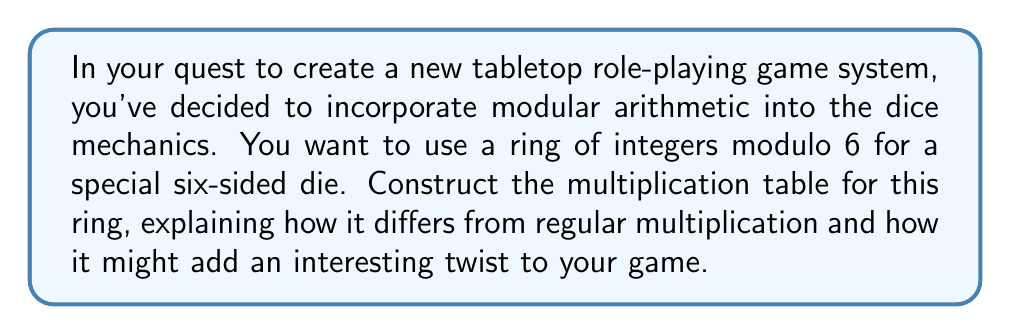Solve this math problem. To construct the multiplication table for the ring of integers modulo 6, we follow these steps:

1) First, recall that in modular arithmetic, we only consider the remainder when dividing by the modulus (in this case, 6). The elements of the ring are $\{0, 1, 2, 3, 4, 5\}$.

2) To multiply two elements $a$ and $b$ in this ring, we:
   a) Multiply $a$ and $b$ as usual
   b) Divide the result by 6
   c) Take the remainder as the answer

3) Let's work through a few examples:
   - $2 \times 3 = 6 \equiv 0 \pmod{6}$
   - $4 \times 5 = 20 \equiv 2 \pmod{6}$
   - $5 \times 5 = 25 \equiv 1 \pmod{6}$

4) Now, let's construct the full multiplication table:

$$
\begin{array}{c|cccccc}
\times & 0 & 1 & 2 & 3 & 4 & 5 \\
\hline
0 & 0 & 0 & 0 & 0 & 0 & 0 \\
1 & 0 & 1 & 2 & 3 & 4 & 5 \\
2 & 0 & 2 & 4 & 0 & 2 & 4 \\
3 & 0 & 3 & 0 & 3 & 0 & 3 \\
4 & 0 & 4 & 2 & 0 & 4 & 2 \\
5 & 0 & 5 & 4 & 3 & 2 & 1
\end{array}
$$

5) This table differs from regular multiplication in several ways:
   - The product is always between 0 and 5
   - Some multiplications that would normally yield larger numbers "wrap around"
   - There are more occurrences of 0 in the table

In a game context, this could add an interesting twist. For example, multiplying high numbers doesn't always yield high results, which could add an element of unpredictability to dice rolls or combat calculations.
Answer: The multiplication table for the ring of integers modulo 6 is:

$$
\begin{array}{c|cccccc}
\times & 0 & 1 & 2 & 3 & 4 & 5 \\
\hline
0 & 0 & 0 & 0 & 0 & 0 & 0 \\
1 & 0 & 1 & 2 & 3 & 4 & 5 \\
2 & 0 & 2 & 4 & 0 & 2 & 4 \\
3 & 0 & 3 & 0 & 3 & 0 & 3 \\
4 & 0 & 4 & 2 & 0 & 4 & 2 \\
5 & 0 & 5 & 4 & 3 & 2 & 1
\end{array}
$$ 